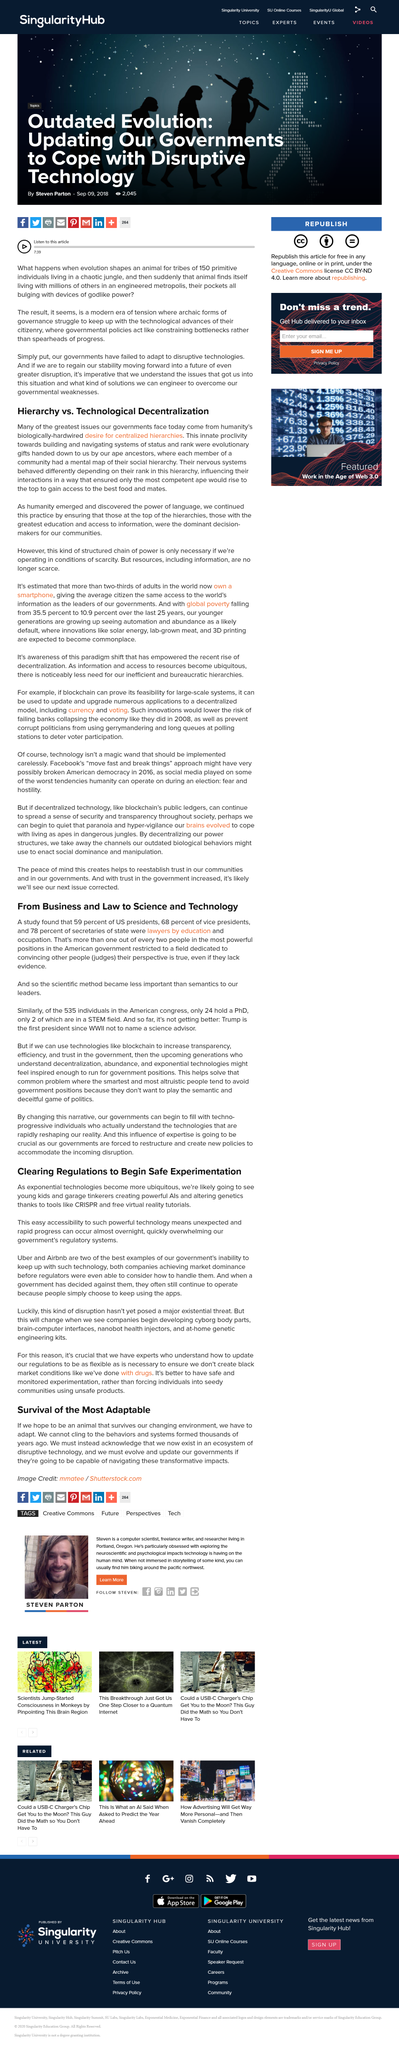Mention a couple of crucial points in this snapshot. It is likely that garage tinkerers will create powerful AIs. The missing small joining word from the sentence "From Business ___ Law to Science ___ Technology" is "to". The complete sentence is "From Business to Law to Science to Technology". The organization system named hierarchy is described in the paragraph. It is likely that young kids will create powerful AIs in the future. The most competent ape at the top of the hierarchy would gain access to the best food and mates. 